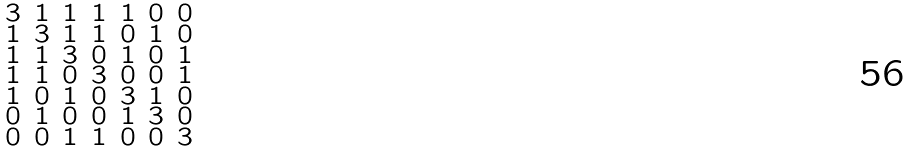<formula> <loc_0><loc_0><loc_500><loc_500>\begin{smallmatrix} 3 & 1 & 1 & 1 & 1 & 0 & 0 \\ 1 & 3 & 1 & 1 & 0 & 1 & 0 \\ 1 & 1 & 3 & 0 & 1 & 0 & 1 \\ 1 & 1 & 0 & 3 & 0 & 0 & 1 \\ 1 & 0 & 1 & 0 & 3 & 1 & 0 \\ 0 & 1 & 0 & 0 & 1 & 3 & 0 \\ 0 & 0 & 1 & 1 & 0 & 0 & 3 \end{smallmatrix}</formula> 